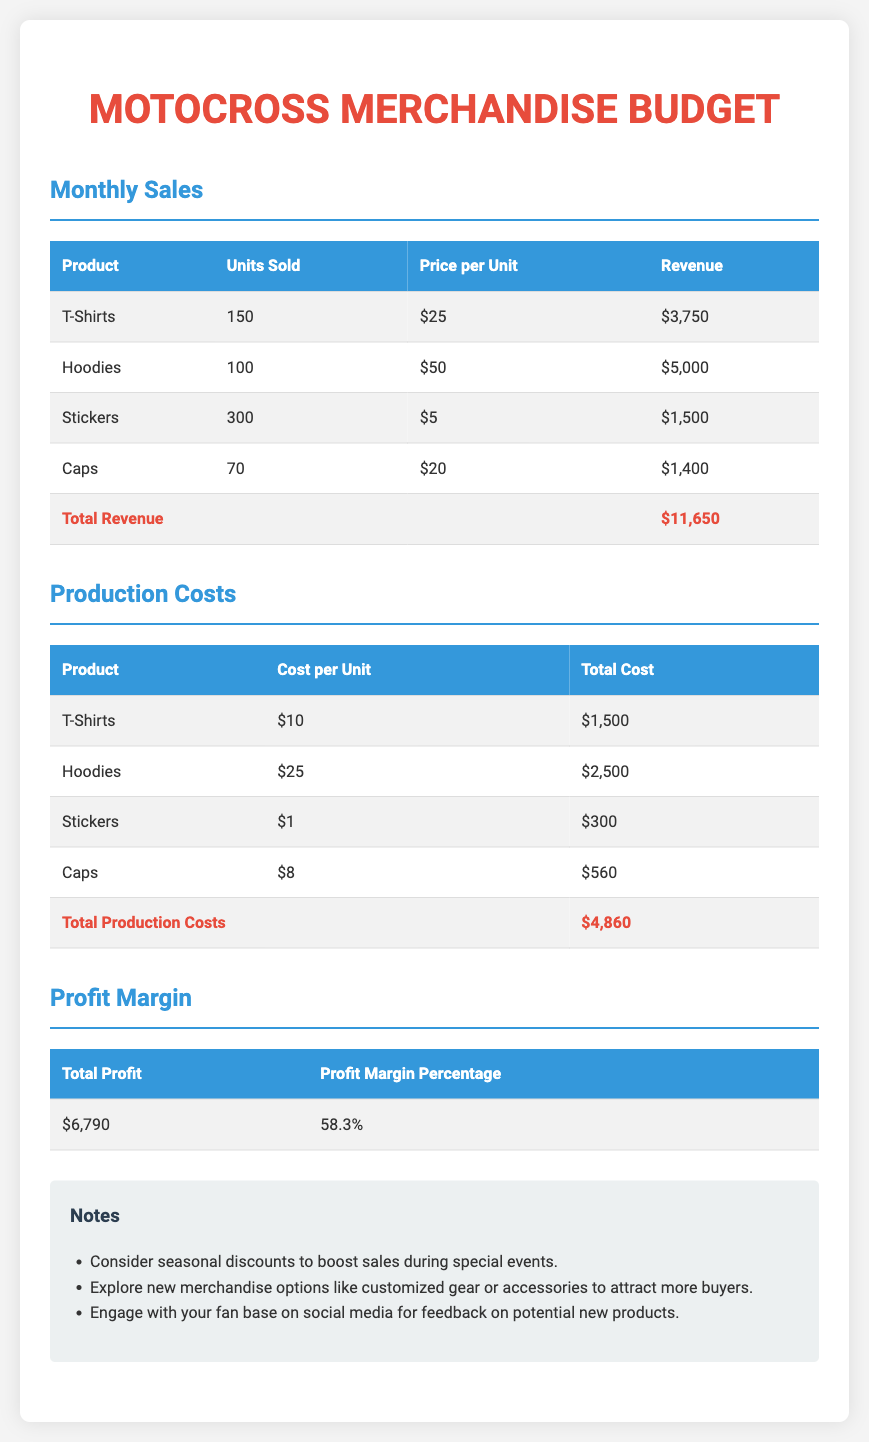What is the total revenue? The total revenue is calculated by adding the revenue from all merchandise products sold, which adds up to $11,650.
Answer: $11,650 What is the total cost for hoodies? The total cost for hoodies is obtained by multiplying the cost per unit by the units sold, which equals $2,500.
Answer: $2,500 How many caps were sold? The number of caps sold is listed under the "Units Sold" column for caps, which is 70.
Answer: 70 What is the profit margin percentage? The profit margin percentage is provided in the dedicated section and is calculated as a percentage of total profit relative to revenue, which is 58.3%.
Answer: 58.3% What is the total production cost? The total production cost is the sum of the costs for all products, which totals $4,860 as shown in the document.
Answer: $4,860 Which product generated the highest revenue? By comparing the revenue figures for each product, it is clear that hoodies generated the highest at $5,000.
Answer: Hoodies What is the total profit? Total profit is found by subtracting total production costs from total revenue, which results in $6,790.
Answer: $6,790 How many stickers were sold? Stickers sold are listed in the table, where the units sold amount to 300.
Answer: 300 What recommendation is made to boost sales? The notes suggest considering seasonal discounts to enhance sales during events, indicating a strategy to increase revenue.
Answer: Seasonal discounts 